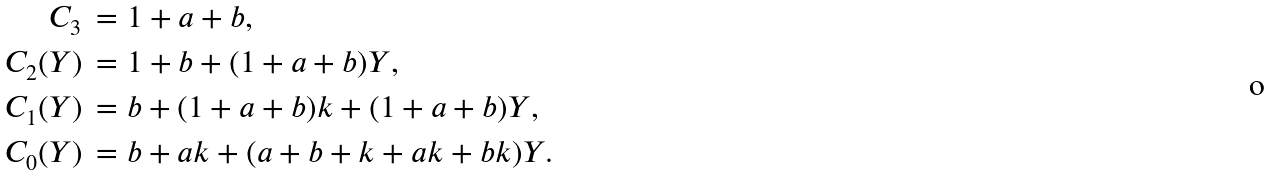Convert formula to latex. <formula><loc_0><loc_0><loc_500><loc_500>C _ { 3 } \, & = 1 + a + b , \\ C _ { 2 } ( Y ) \, & = 1 + b + ( 1 + a + b ) Y , \\ C _ { 1 } ( Y ) \, & = b + ( 1 + a + b ) k + ( 1 + a + b ) Y , \\ C _ { 0 } ( Y ) \, & = b + a k + ( a + b + k + a k + b k ) Y .</formula> 